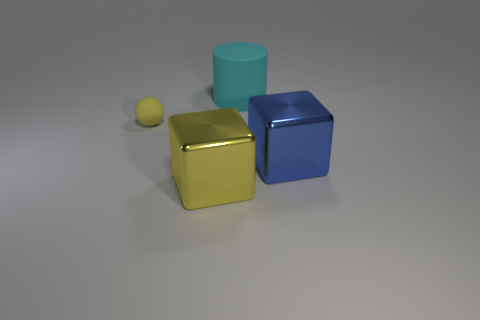Is the number of large yellow metallic things greater than the number of gray spheres? Yes, the number of large yellow metallic things, which appears to be one large yellow cube, is greater than the number of gray spheres, as there is only a single small gray sphere present. 